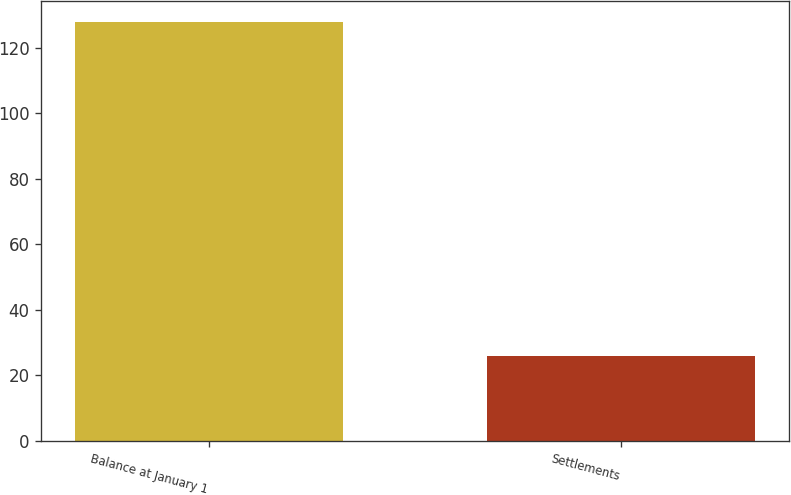Convert chart to OTSL. <chart><loc_0><loc_0><loc_500><loc_500><bar_chart><fcel>Balance at January 1<fcel>Settlements<nl><fcel>128<fcel>26<nl></chart> 